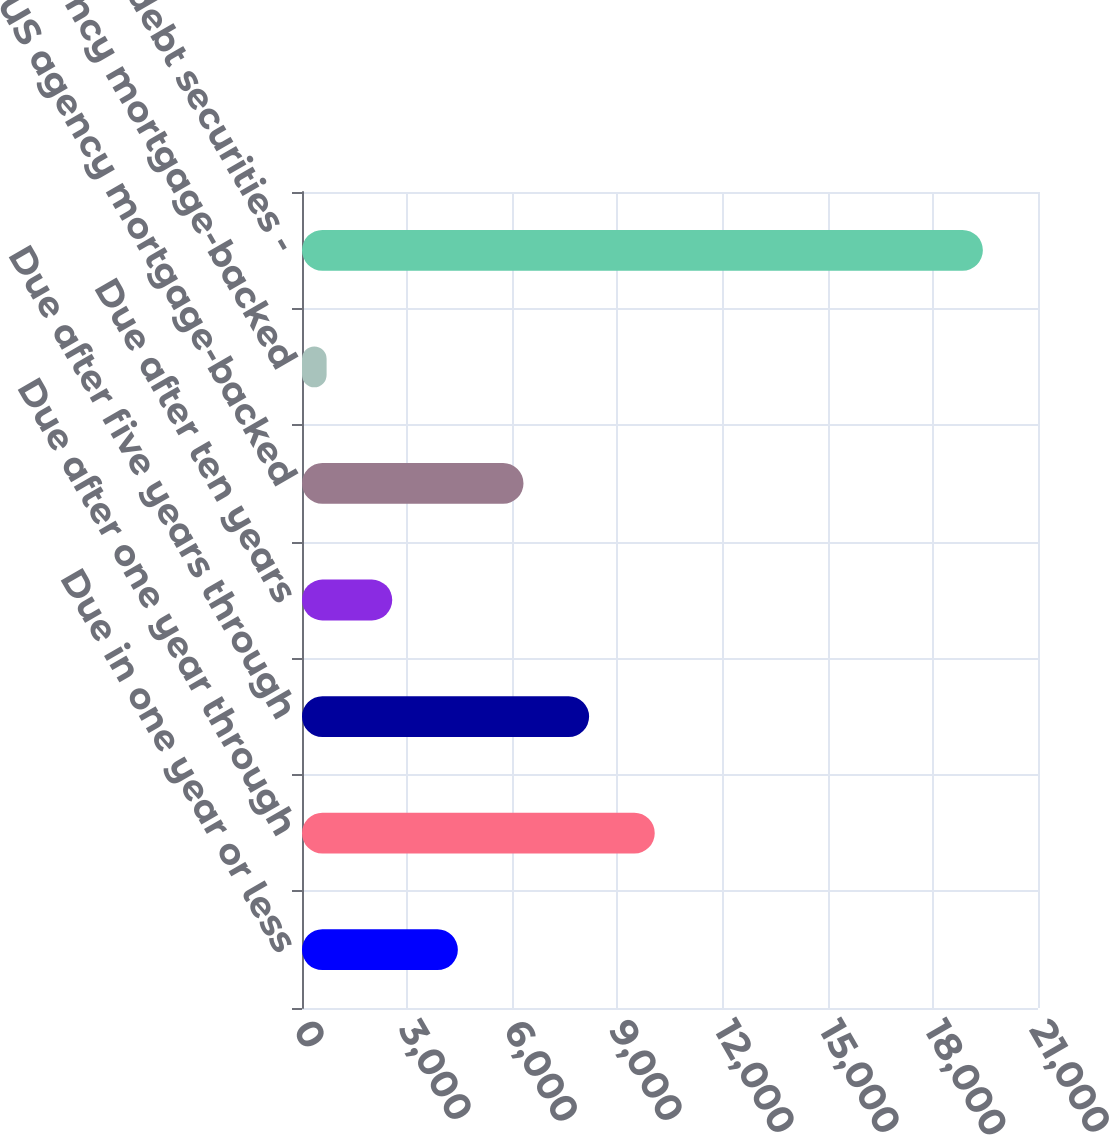Convert chart to OTSL. <chart><loc_0><loc_0><loc_500><loc_500><bar_chart><fcel>Due in one year or less<fcel>Due after one year through<fcel>Due after five years through<fcel>Due after ten years<fcel>US agency mortgage-backed<fcel>Non-US agency mortgage-backed<fcel>Total debt securities -<nl><fcel>4447<fcel>10064.5<fcel>8192<fcel>2574.5<fcel>6319.5<fcel>702<fcel>19427<nl></chart> 